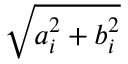<formula> <loc_0><loc_0><loc_500><loc_500>\sqrt { a _ { i } ^ { 2 } + b _ { i } ^ { 2 } }</formula> 